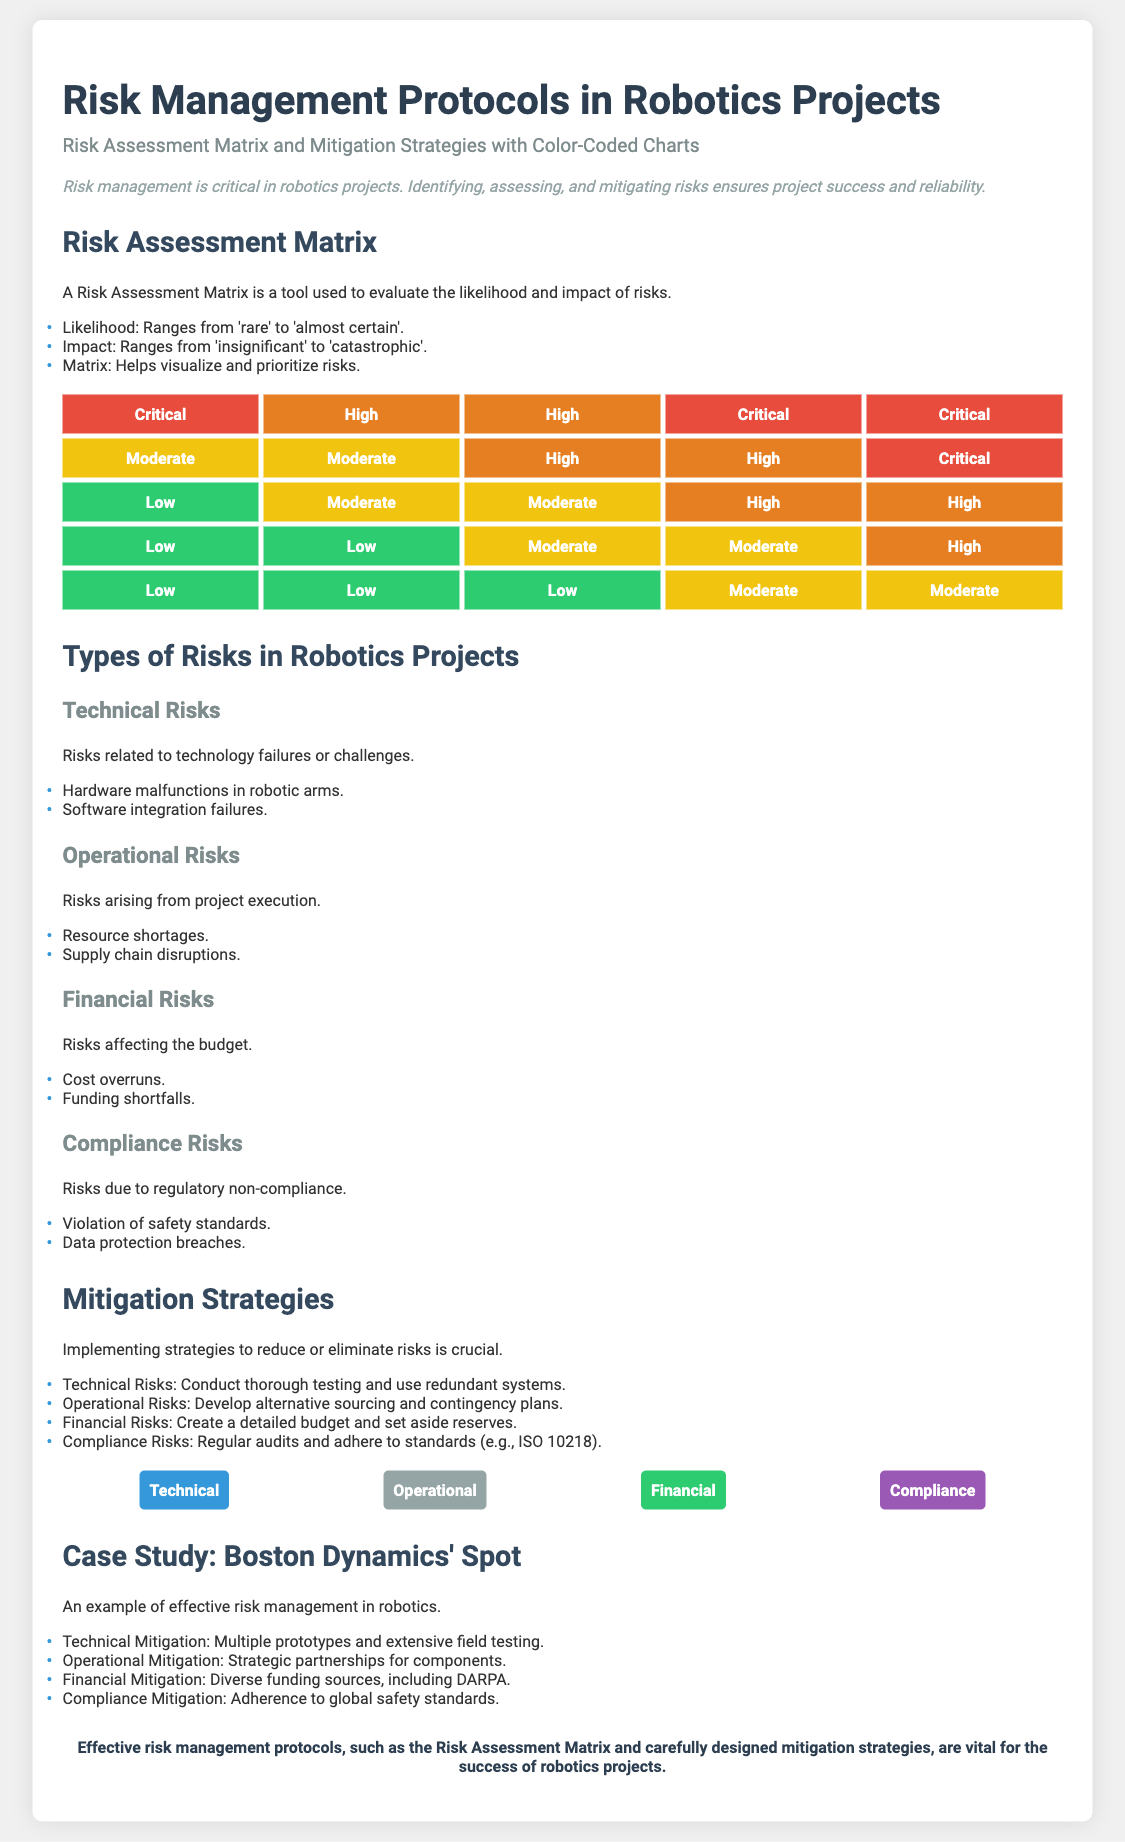What is the title of the presentation? The title of the presentation is provided at the top of the document and states the main topic.
Answer: Risk Management Protocols in Robotics Projects What does the Risk Assessment Matrix evaluate? The document specifies that the Risk Assessment Matrix evaluates both likelihood and impact of risks.
Answer: Likelihood and impact How many types of risks in robotics projects are identified? The document lists four categories of risks related to robotics projects.
Answer: Four Which color represents 'Critical' risks in the matrix? The risk matrix uses color coding, with specific colors for different risk levels.
Answer: Red What is one strategy to mitigate Technical Risks? The document provides an example of a strategy for mitigating technical risks among other types.
Answer: Conduct thorough testing Which type of risk involves regulatory non-compliance? The presentation categorizes risks and describes the consequences of each type, including the specific nature of compliance risks.
Answer: Compliance Risks How does the document describe the case study on Boston Dynamics' Spot? The document briefly mentions the effectiveness of risk management in the context of a specific robotics project.
Answer: Example of effective risk management What is the recommended response to Financial Risks? The document suggests a specific action to handle financial risks effectively within a project context.
Answer: Create a detailed budget Which color is used for Operational mitigation strategies? The document uses distinct colors for different mitigation types, and the color for operational strategies is mentioned.
Answer: Teal 